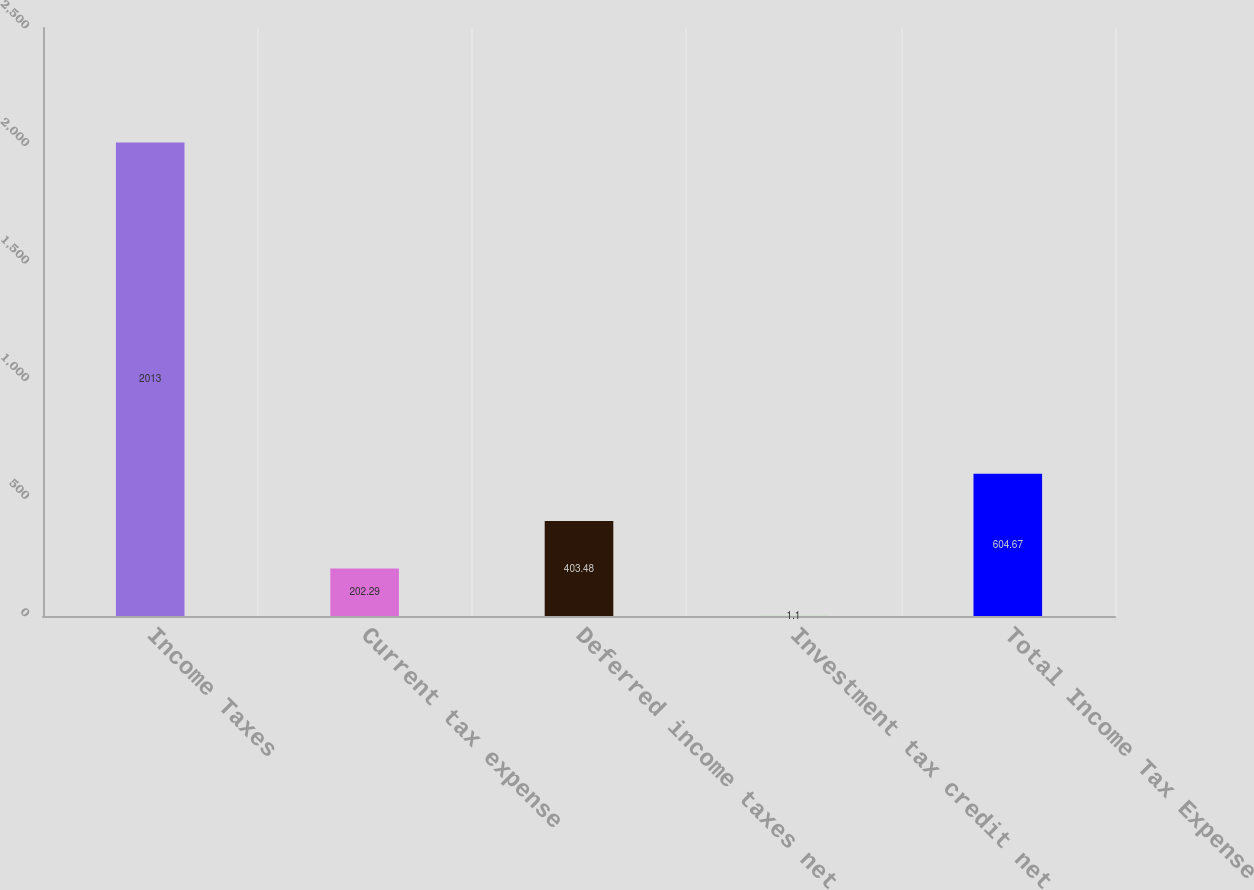Convert chart to OTSL. <chart><loc_0><loc_0><loc_500><loc_500><bar_chart><fcel>Income Taxes<fcel>Current tax expense<fcel>Deferred income taxes net<fcel>Investment tax credit net<fcel>Total Income Tax Expense<nl><fcel>2013<fcel>202.29<fcel>403.48<fcel>1.1<fcel>604.67<nl></chart> 